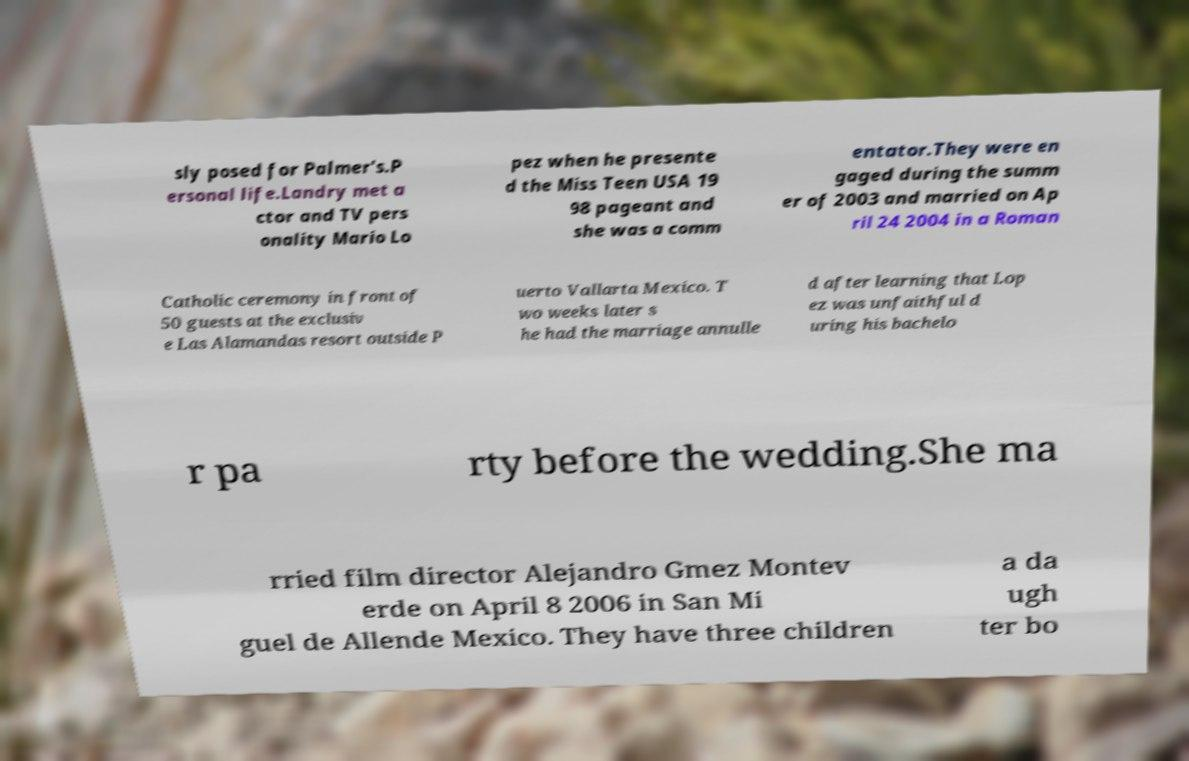Please identify and transcribe the text found in this image. sly posed for Palmer's.P ersonal life.Landry met a ctor and TV pers onality Mario Lo pez when he presente d the Miss Teen USA 19 98 pageant and she was a comm entator.They were en gaged during the summ er of 2003 and married on Ap ril 24 2004 in a Roman Catholic ceremony in front of 50 guests at the exclusiv e Las Alamandas resort outside P uerto Vallarta Mexico. T wo weeks later s he had the marriage annulle d after learning that Lop ez was unfaithful d uring his bachelo r pa rty before the wedding.She ma rried film director Alejandro Gmez Montev erde on April 8 2006 in San Mi guel de Allende Mexico. They have three children a da ugh ter bo 